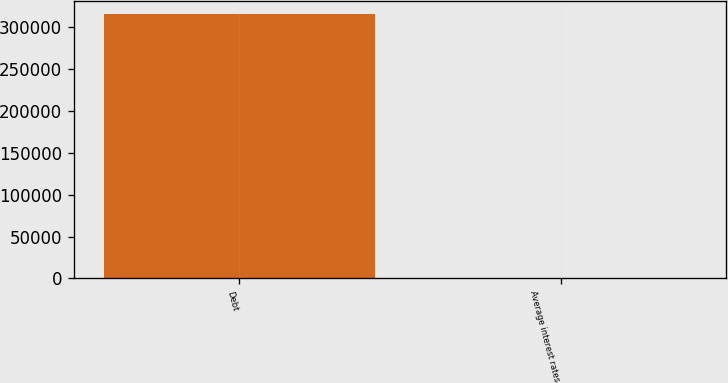Convert chart to OTSL. <chart><loc_0><loc_0><loc_500><loc_500><bar_chart><fcel>Debt<fcel>Average interest rates<nl><fcel>315298<fcel>5<nl></chart> 